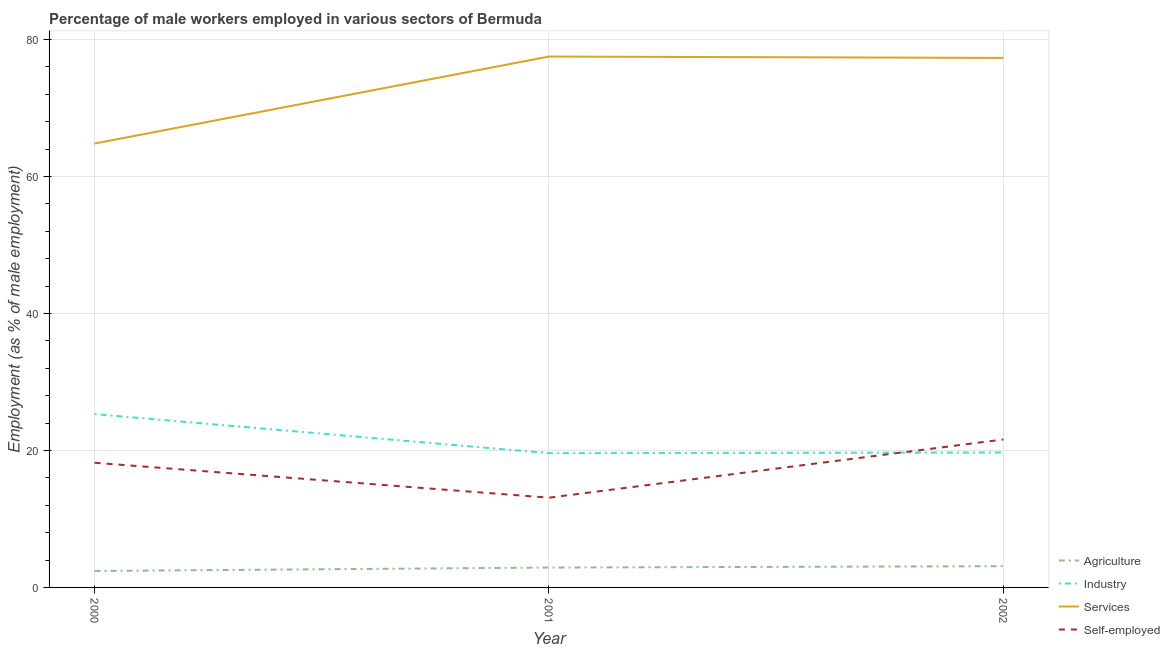What is the percentage of male workers in industry in 2000?
Provide a succinct answer. 25.3. Across all years, what is the maximum percentage of self employed male workers?
Your answer should be compact. 21.6. Across all years, what is the minimum percentage of male workers in agriculture?
Give a very brief answer. 2.4. In which year was the percentage of male workers in agriculture maximum?
Give a very brief answer. 2002. What is the total percentage of male workers in services in the graph?
Make the answer very short. 219.6. What is the difference between the percentage of self employed male workers in 2000 and that in 2002?
Your answer should be very brief. -3.4. What is the difference between the percentage of male workers in services in 2000 and the percentage of self employed male workers in 2001?
Your answer should be very brief. 51.7. What is the average percentage of male workers in industry per year?
Your answer should be compact. 21.53. In the year 2000, what is the difference between the percentage of male workers in industry and percentage of self employed male workers?
Provide a succinct answer. 7.1. What is the ratio of the percentage of self employed male workers in 2000 to that in 2001?
Your answer should be very brief. 1.39. Is the percentage of male workers in agriculture in 2000 less than that in 2001?
Provide a short and direct response. Yes. What is the difference between the highest and the second highest percentage of self employed male workers?
Offer a very short reply. 3.4. What is the difference between the highest and the lowest percentage of male workers in services?
Your answer should be compact. 12.7. Is the sum of the percentage of male workers in services in 2001 and 2002 greater than the maximum percentage of male workers in industry across all years?
Keep it short and to the point. Yes. Is it the case that in every year, the sum of the percentage of male workers in agriculture and percentage of self employed male workers is greater than the sum of percentage of male workers in services and percentage of male workers in industry?
Your response must be concise. No. Does the percentage of male workers in agriculture monotonically increase over the years?
Make the answer very short. Yes. Is the percentage of self employed male workers strictly greater than the percentage of male workers in agriculture over the years?
Provide a short and direct response. Yes. Is the percentage of self employed male workers strictly less than the percentage of male workers in services over the years?
Give a very brief answer. Yes. How many years are there in the graph?
Provide a succinct answer. 3. Are the values on the major ticks of Y-axis written in scientific E-notation?
Your answer should be very brief. No. Does the graph contain grids?
Ensure brevity in your answer.  Yes. How are the legend labels stacked?
Your answer should be compact. Vertical. What is the title of the graph?
Offer a terse response. Percentage of male workers employed in various sectors of Bermuda. Does "Secondary vocational education" appear as one of the legend labels in the graph?
Ensure brevity in your answer.  No. What is the label or title of the X-axis?
Give a very brief answer. Year. What is the label or title of the Y-axis?
Provide a short and direct response. Employment (as % of male employment). What is the Employment (as % of male employment) in Agriculture in 2000?
Ensure brevity in your answer.  2.4. What is the Employment (as % of male employment) of Industry in 2000?
Provide a succinct answer. 25.3. What is the Employment (as % of male employment) of Services in 2000?
Your answer should be very brief. 64.8. What is the Employment (as % of male employment) in Self-employed in 2000?
Provide a short and direct response. 18.2. What is the Employment (as % of male employment) of Agriculture in 2001?
Your answer should be compact. 2.9. What is the Employment (as % of male employment) in Industry in 2001?
Provide a succinct answer. 19.6. What is the Employment (as % of male employment) of Services in 2001?
Keep it short and to the point. 77.5. What is the Employment (as % of male employment) of Self-employed in 2001?
Give a very brief answer. 13.1. What is the Employment (as % of male employment) of Agriculture in 2002?
Your answer should be compact. 3.1. What is the Employment (as % of male employment) in Industry in 2002?
Your answer should be compact. 19.7. What is the Employment (as % of male employment) in Services in 2002?
Give a very brief answer. 77.3. What is the Employment (as % of male employment) in Self-employed in 2002?
Offer a very short reply. 21.6. Across all years, what is the maximum Employment (as % of male employment) in Agriculture?
Provide a succinct answer. 3.1. Across all years, what is the maximum Employment (as % of male employment) in Industry?
Give a very brief answer. 25.3. Across all years, what is the maximum Employment (as % of male employment) of Services?
Offer a very short reply. 77.5. Across all years, what is the maximum Employment (as % of male employment) of Self-employed?
Provide a short and direct response. 21.6. Across all years, what is the minimum Employment (as % of male employment) of Agriculture?
Your response must be concise. 2.4. Across all years, what is the minimum Employment (as % of male employment) of Industry?
Give a very brief answer. 19.6. Across all years, what is the minimum Employment (as % of male employment) of Services?
Give a very brief answer. 64.8. Across all years, what is the minimum Employment (as % of male employment) of Self-employed?
Provide a short and direct response. 13.1. What is the total Employment (as % of male employment) in Industry in the graph?
Give a very brief answer. 64.6. What is the total Employment (as % of male employment) of Services in the graph?
Offer a very short reply. 219.6. What is the total Employment (as % of male employment) in Self-employed in the graph?
Give a very brief answer. 52.9. What is the difference between the Employment (as % of male employment) in Industry in 2000 and that in 2001?
Make the answer very short. 5.7. What is the difference between the Employment (as % of male employment) of Self-employed in 2000 and that in 2001?
Your response must be concise. 5.1. What is the difference between the Employment (as % of male employment) of Agriculture in 2000 and that in 2002?
Your answer should be very brief. -0.7. What is the difference between the Employment (as % of male employment) of Industry in 2000 and that in 2002?
Your answer should be very brief. 5.6. What is the difference between the Employment (as % of male employment) in Services in 2001 and that in 2002?
Provide a short and direct response. 0.2. What is the difference between the Employment (as % of male employment) in Self-employed in 2001 and that in 2002?
Your answer should be compact. -8.5. What is the difference between the Employment (as % of male employment) in Agriculture in 2000 and the Employment (as % of male employment) in Industry in 2001?
Keep it short and to the point. -17.2. What is the difference between the Employment (as % of male employment) in Agriculture in 2000 and the Employment (as % of male employment) in Services in 2001?
Provide a succinct answer. -75.1. What is the difference between the Employment (as % of male employment) in Industry in 2000 and the Employment (as % of male employment) in Services in 2001?
Provide a short and direct response. -52.2. What is the difference between the Employment (as % of male employment) in Services in 2000 and the Employment (as % of male employment) in Self-employed in 2001?
Ensure brevity in your answer.  51.7. What is the difference between the Employment (as % of male employment) of Agriculture in 2000 and the Employment (as % of male employment) of Industry in 2002?
Your answer should be very brief. -17.3. What is the difference between the Employment (as % of male employment) in Agriculture in 2000 and the Employment (as % of male employment) in Services in 2002?
Provide a short and direct response. -74.9. What is the difference between the Employment (as % of male employment) in Agriculture in 2000 and the Employment (as % of male employment) in Self-employed in 2002?
Keep it short and to the point. -19.2. What is the difference between the Employment (as % of male employment) of Industry in 2000 and the Employment (as % of male employment) of Services in 2002?
Your answer should be compact. -52. What is the difference between the Employment (as % of male employment) of Industry in 2000 and the Employment (as % of male employment) of Self-employed in 2002?
Your answer should be compact. 3.7. What is the difference between the Employment (as % of male employment) of Services in 2000 and the Employment (as % of male employment) of Self-employed in 2002?
Make the answer very short. 43.2. What is the difference between the Employment (as % of male employment) in Agriculture in 2001 and the Employment (as % of male employment) in Industry in 2002?
Provide a short and direct response. -16.8. What is the difference between the Employment (as % of male employment) of Agriculture in 2001 and the Employment (as % of male employment) of Services in 2002?
Offer a terse response. -74.4. What is the difference between the Employment (as % of male employment) in Agriculture in 2001 and the Employment (as % of male employment) in Self-employed in 2002?
Provide a succinct answer. -18.7. What is the difference between the Employment (as % of male employment) of Industry in 2001 and the Employment (as % of male employment) of Services in 2002?
Make the answer very short. -57.7. What is the difference between the Employment (as % of male employment) in Services in 2001 and the Employment (as % of male employment) in Self-employed in 2002?
Your answer should be very brief. 55.9. What is the average Employment (as % of male employment) of Agriculture per year?
Give a very brief answer. 2.8. What is the average Employment (as % of male employment) of Industry per year?
Offer a terse response. 21.53. What is the average Employment (as % of male employment) in Services per year?
Your response must be concise. 73.2. What is the average Employment (as % of male employment) in Self-employed per year?
Your response must be concise. 17.63. In the year 2000, what is the difference between the Employment (as % of male employment) in Agriculture and Employment (as % of male employment) in Industry?
Give a very brief answer. -22.9. In the year 2000, what is the difference between the Employment (as % of male employment) in Agriculture and Employment (as % of male employment) in Services?
Provide a short and direct response. -62.4. In the year 2000, what is the difference between the Employment (as % of male employment) in Agriculture and Employment (as % of male employment) in Self-employed?
Your answer should be compact. -15.8. In the year 2000, what is the difference between the Employment (as % of male employment) of Industry and Employment (as % of male employment) of Services?
Your response must be concise. -39.5. In the year 2000, what is the difference between the Employment (as % of male employment) of Services and Employment (as % of male employment) of Self-employed?
Make the answer very short. 46.6. In the year 2001, what is the difference between the Employment (as % of male employment) in Agriculture and Employment (as % of male employment) in Industry?
Provide a succinct answer. -16.7. In the year 2001, what is the difference between the Employment (as % of male employment) in Agriculture and Employment (as % of male employment) in Services?
Offer a very short reply. -74.6. In the year 2001, what is the difference between the Employment (as % of male employment) in Industry and Employment (as % of male employment) in Services?
Give a very brief answer. -57.9. In the year 2001, what is the difference between the Employment (as % of male employment) in Industry and Employment (as % of male employment) in Self-employed?
Offer a very short reply. 6.5. In the year 2001, what is the difference between the Employment (as % of male employment) in Services and Employment (as % of male employment) in Self-employed?
Make the answer very short. 64.4. In the year 2002, what is the difference between the Employment (as % of male employment) in Agriculture and Employment (as % of male employment) in Industry?
Ensure brevity in your answer.  -16.6. In the year 2002, what is the difference between the Employment (as % of male employment) of Agriculture and Employment (as % of male employment) of Services?
Your answer should be compact. -74.2. In the year 2002, what is the difference between the Employment (as % of male employment) in Agriculture and Employment (as % of male employment) in Self-employed?
Ensure brevity in your answer.  -18.5. In the year 2002, what is the difference between the Employment (as % of male employment) of Industry and Employment (as % of male employment) of Services?
Offer a terse response. -57.6. In the year 2002, what is the difference between the Employment (as % of male employment) in Industry and Employment (as % of male employment) in Self-employed?
Offer a very short reply. -1.9. In the year 2002, what is the difference between the Employment (as % of male employment) of Services and Employment (as % of male employment) of Self-employed?
Your answer should be very brief. 55.7. What is the ratio of the Employment (as % of male employment) in Agriculture in 2000 to that in 2001?
Make the answer very short. 0.83. What is the ratio of the Employment (as % of male employment) of Industry in 2000 to that in 2001?
Your answer should be compact. 1.29. What is the ratio of the Employment (as % of male employment) of Services in 2000 to that in 2001?
Your answer should be very brief. 0.84. What is the ratio of the Employment (as % of male employment) in Self-employed in 2000 to that in 2001?
Give a very brief answer. 1.39. What is the ratio of the Employment (as % of male employment) in Agriculture in 2000 to that in 2002?
Give a very brief answer. 0.77. What is the ratio of the Employment (as % of male employment) of Industry in 2000 to that in 2002?
Offer a very short reply. 1.28. What is the ratio of the Employment (as % of male employment) of Services in 2000 to that in 2002?
Provide a short and direct response. 0.84. What is the ratio of the Employment (as % of male employment) of Self-employed in 2000 to that in 2002?
Offer a very short reply. 0.84. What is the ratio of the Employment (as % of male employment) of Agriculture in 2001 to that in 2002?
Offer a terse response. 0.94. What is the ratio of the Employment (as % of male employment) of Services in 2001 to that in 2002?
Your response must be concise. 1. What is the ratio of the Employment (as % of male employment) of Self-employed in 2001 to that in 2002?
Give a very brief answer. 0.61. What is the difference between the highest and the second highest Employment (as % of male employment) of Industry?
Keep it short and to the point. 5.6. What is the difference between the highest and the second highest Employment (as % of male employment) of Self-employed?
Give a very brief answer. 3.4. What is the difference between the highest and the lowest Employment (as % of male employment) in Agriculture?
Your answer should be very brief. 0.7. What is the difference between the highest and the lowest Employment (as % of male employment) of Industry?
Ensure brevity in your answer.  5.7. 